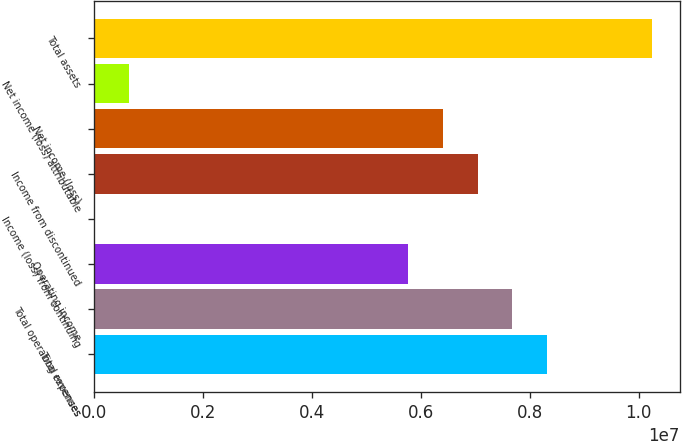<chart> <loc_0><loc_0><loc_500><loc_500><bar_chart><fcel>Total revenues<fcel>Total operating expenses<fcel>Operating income<fcel>Income (loss) from continuing<fcel>Income from discontinued<fcel>Net income (loss)<fcel>Net income (loss) attributable<fcel>Total assets<nl><fcel>8.32179e+06<fcel>7.68166e+06<fcel>5.76124e+06<fcel>0.6<fcel>7.04152e+06<fcel>6.40138e+06<fcel>640139<fcel>1.02422e+07<nl></chart> 